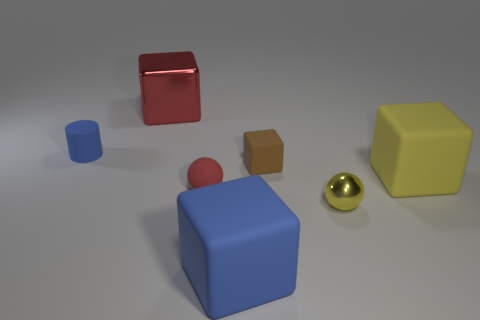There is a blue rubber thing that is in front of the large matte block that is right of the small brown matte object; are there any things in front of it?
Offer a very short reply. No. How many things are rubber cubes or cyan metal balls?
Make the answer very short. 3. Does the tiny red sphere have the same material as the thing that is on the left side of the metal block?
Provide a succinct answer. Yes. Is there any other thing that is the same color as the big metal block?
Keep it short and to the point. Yes. How many things are either small things that are left of the red matte object or rubber blocks behind the big yellow cube?
Provide a succinct answer. 2. There is a large thing that is to the left of the yellow shiny object and behind the large blue object; what shape is it?
Your answer should be compact. Cube. How many small blue matte objects are in front of the yellow thing on the left side of the big yellow matte block?
Keep it short and to the point. 0. What number of things are big blocks that are in front of the red metallic thing or large objects?
Your response must be concise. 3. There is a cube in front of the small yellow object; what is its size?
Give a very brief answer. Large. What is the red ball made of?
Your response must be concise. Rubber. 